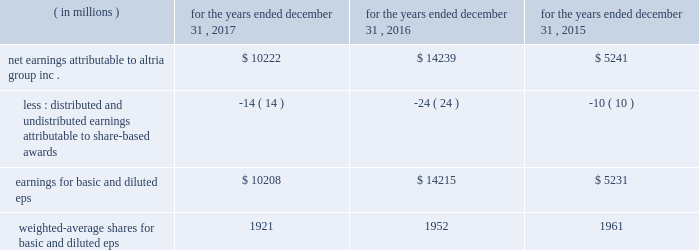10-k altria ar release tuesday , february 27 , 2018 10:00pm andra design llc performance stock units : in january 2017 , altria group , inc .
Granted an aggregate of 187886 performance stock units to eligible employees .
The payout of the performance stock units requires the achievement of certain performance measures , which were predetermined at the time of grant , over a three-year performance cycle .
These performance measures consist of altria group , inc . 2019s adjusted diluted earnings per share ( 201ceps 201d ) compounded annual growth rate and altria group , inc . 2019s total shareholder return relative to a predetermined peer group .
The performance stock units are also subject to forfeiture if certain employment conditions are not met .
At december 31 , 2017 , altria group , inc .
Had 170755 performance stock units remaining , with a weighted-average grant date fair value of $ 70.39 per performance stock unit .
The fair value of the performance stock units at the date of grant , net of estimated forfeitures , is amortized to expense over the performance period .
Altria group , inc .
Recorded pre-tax compensation expense related to performance stock units for the year ended december 31 , 2017 of $ 6 million .
The unamortized compensation expense related to altria group , inc . 2019s performance stock units was $ 7 million at december 31 , 2017 .
Altria group , inc .
Did not grant any performance stock units during 2016 and 2015 .
Note 12 .
Earnings per share basic and diluted eps were calculated using the following: .
Net earnings attributable to altria group , inc .
$ 10222 $ 14239 $ 5241 less : distributed and undistributed earnings attributable to share-based awards ( 14 ) ( 24 ) ( 10 ) earnings for basic and diluted eps $ 10208 $ 14215 $ 5231 weighted-average shares for basic and diluted eps 1921 1952 1961 .
What is the growth rate in net earnings attributable to altria group inc . in 2016? 
Computations: ((14239 - 5241) / 5241)
Answer: 1.71685. 10-k altria ar release tuesday , february 27 , 2018 10:00pm andra design llc performance stock units : in january 2017 , altria group , inc .
Granted an aggregate of 187886 performance stock units to eligible employees .
The payout of the performance stock units requires the achievement of certain performance measures , which were predetermined at the time of grant , over a three-year performance cycle .
These performance measures consist of altria group , inc . 2019s adjusted diluted earnings per share ( 201ceps 201d ) compounded annual growth rate and altria group , inc . 2019s total shareholder return relative to a predetermined peer group .
The performance stock units are also subject to forfeiture if certain employment conditions are not met .
At december 31 , 2017 , altria group , inc .
Had 170755 performance stock units remaining , with a weighted-average grant date fair value of $ 70.39 per performance stock unit .
The fair value of the performance stock units at the date of grant , net of estimated forfeitures , is amortized to expense over the performance period .
Altria group , inc .
Recorded pre-tax compensation expense related to performance stock units for the year ended december 31 , 2017 of $ 6 million .
The unamortized compensation expense related to altria group , inc . 2019s performance stock units was $ 7 million at december 31 , 2017 .
Altria group , inc .
Did not grant any performance stock units during 2016 and 2015 .
Note 12 .
Earnings per share basic and diluted eps were calculated using the following: .
Net earnings attributable to altria group , inc .
$ 10222 $ 14239 $ 5241 less : distributed and undistributed earnings attributable to share-based awards ( 14 ) ( 24 ) ( 10 ) earnings for basic and diluted eps $ 10208 $ 14215 $ 5231 weighted-average shares for basic and diluted eps 1921 1952 1961 .
What is the growth rate in net earnings attributable to altria group inc . in 2017? 
Computations: ((10222 - 14239) / 14239)
Answer: -0.28211. 